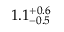Convert formula to latex. <formula><loc_0><loc_0><loc_500><loc_500>1 . 1 _ { - 0 . 5 } ^ { + 0 . 6 }</formula> 